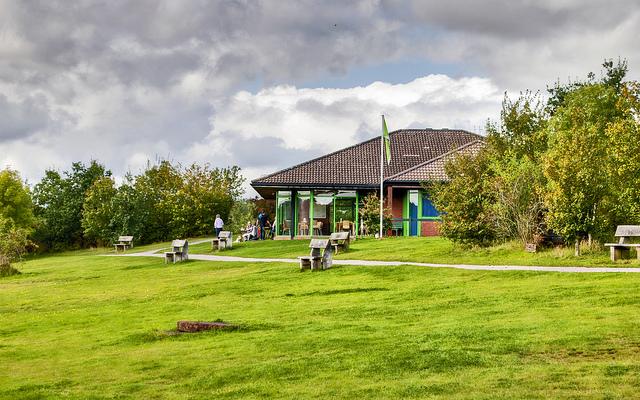What is under the roof?
Short answer required. House. What are the benches made out of?
Answer briefly. Wood. What color is the flag?
Write a very short answer. Green. What kind of building is in the picture?
Keep it brief. House. Is it about to rain?
Answer briefly. Yes. 